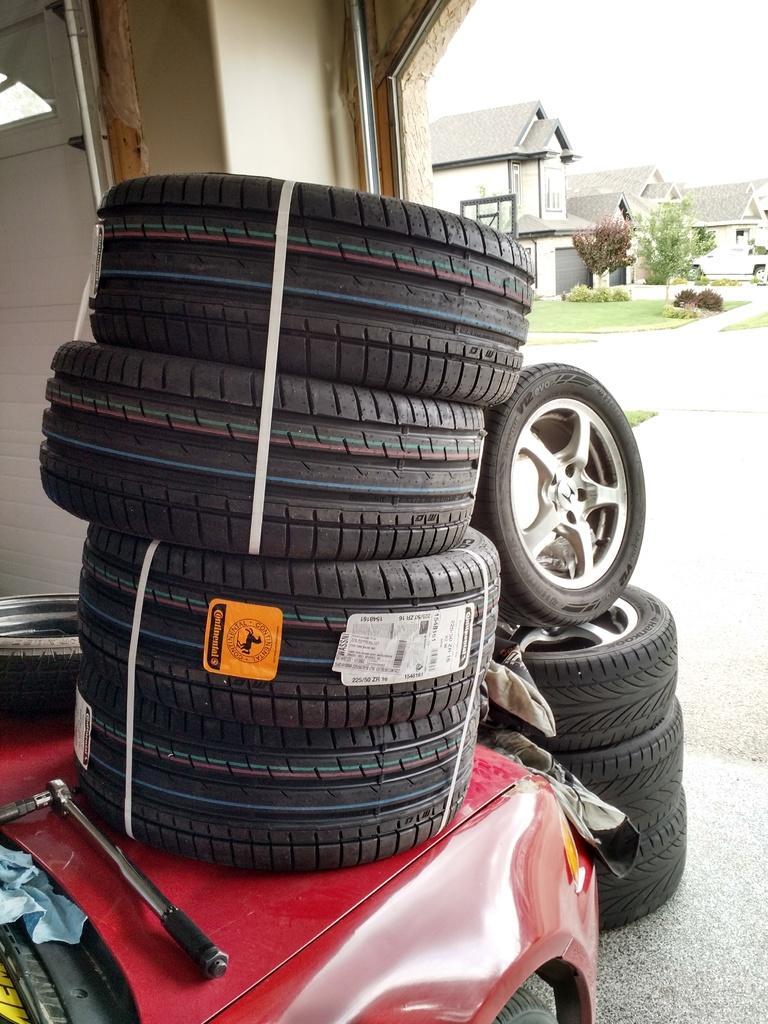Describe this image in one or two sentences. In this picture we can see a vehicle on the ground, here we can see tyres and in the background we can see houses, trees, sky. 